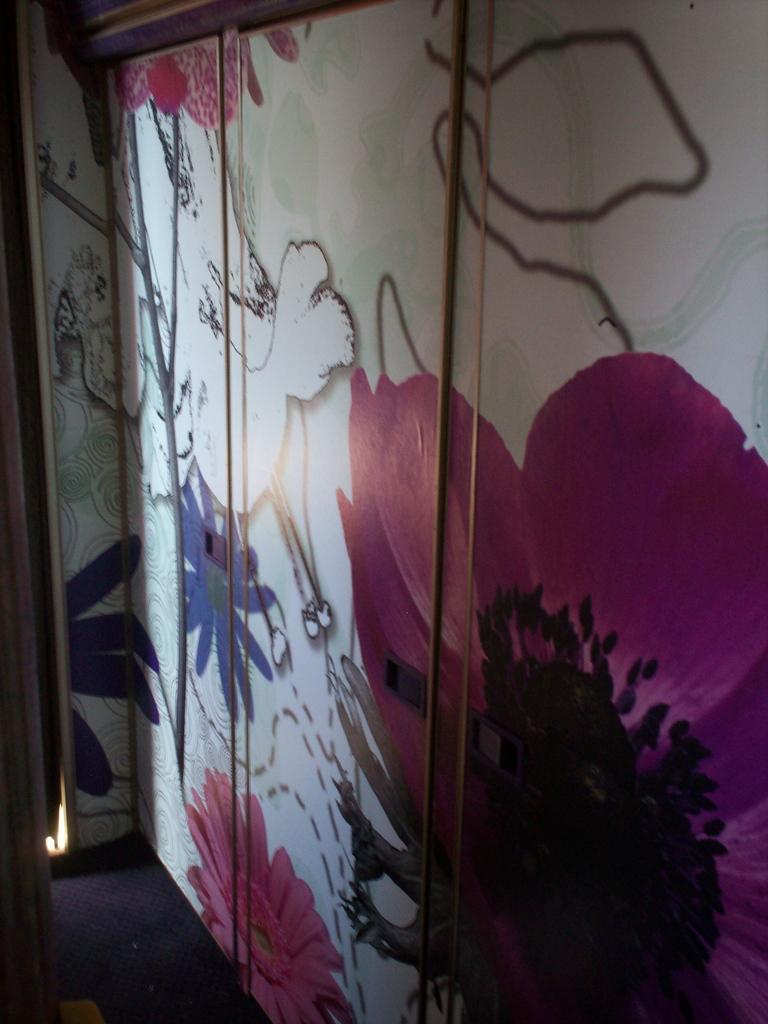In one or two sentences, can you explain what this image depicts? This picture shows a cupboard. we see design on the doors. 